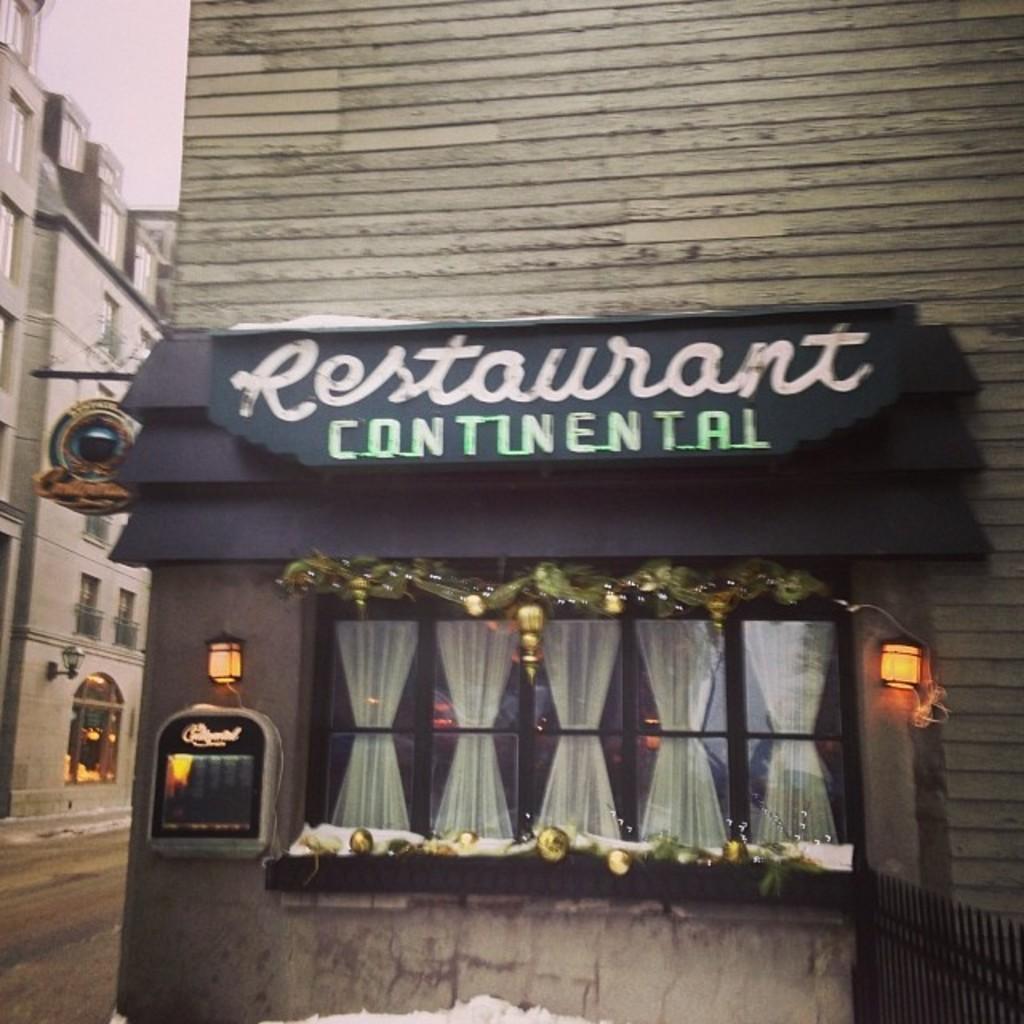Please provide a concise description of this image. In this picture there are buildings. In the foreground there is a board on the wall and there is a text on the board and there are curtains behind the window and there are lights and there is a device on the wall. At the bottom right there is a railing. At the top there is sky. At the bottom there is a road and there is snow. 